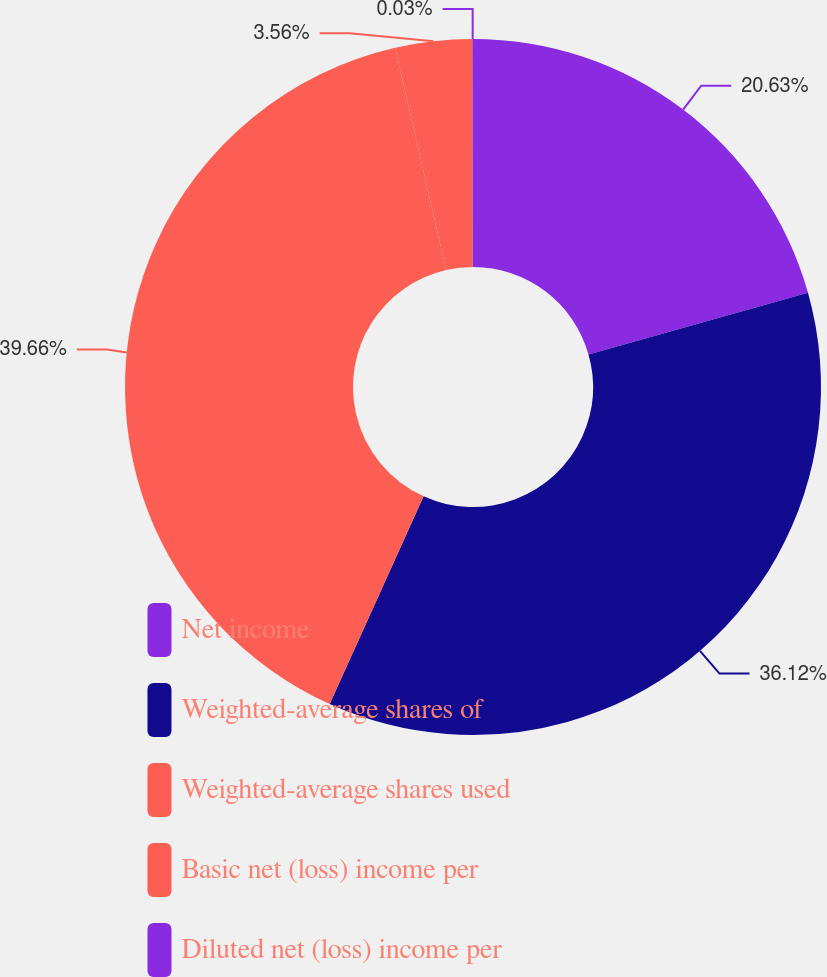Convert chart. <chart><loc_0><loc_0><loc_500><loc_500><pie_chart><fcel>Net income<fcel>Weighted-average shares of<fcel>Weighted-average shares used<fcel>Basic net (loss) income per<fcel>Diluted net (loss) income per<nl><fcel>20.63%<fcel>36.12%<fcel>39.65%<fcel>3.56%<fcel>0.03%<nl></chart> 